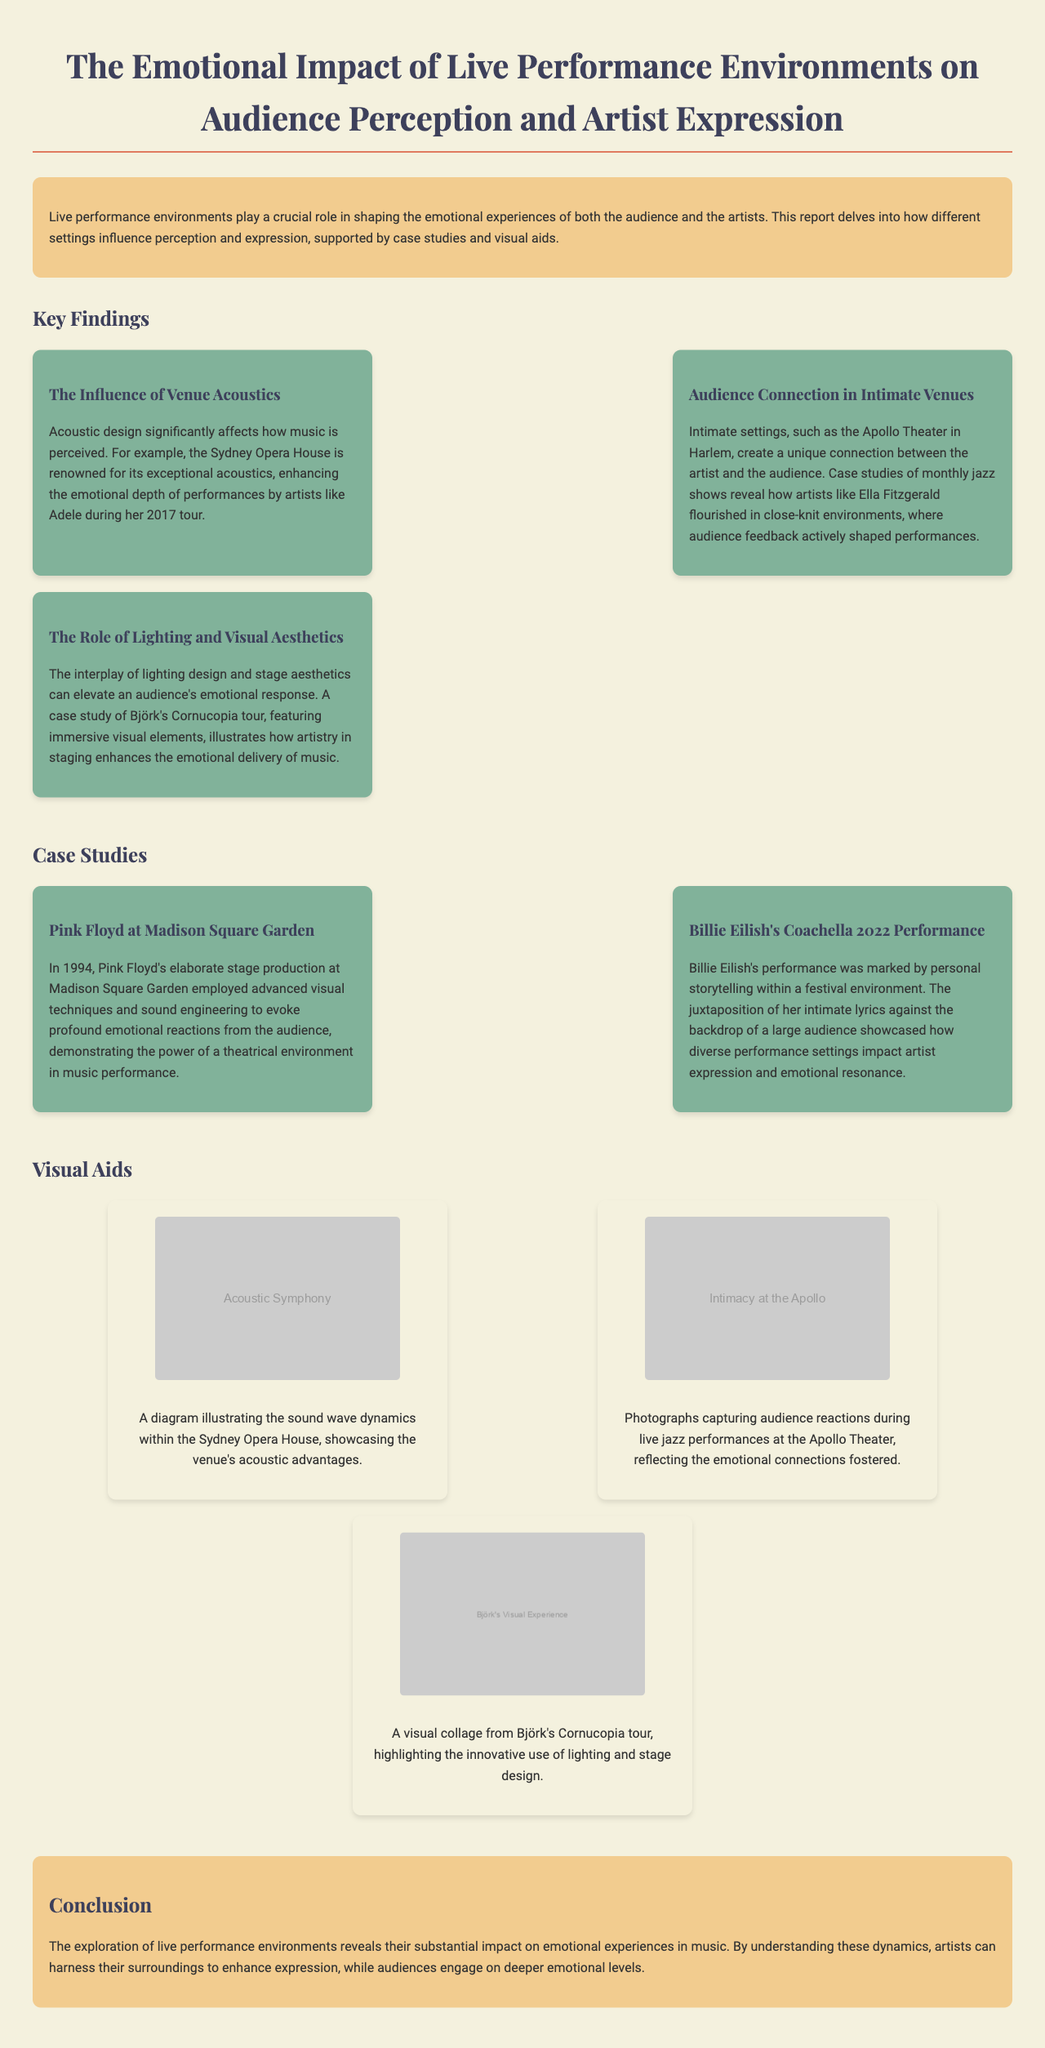what is the title of the report? The title is prominently displayed at the top of the document, indicating the subject matter of the report.
Answer: The Emotional Impact of Live Performance Environments on Audience Perception and Artist Expression who is highlighted for exceptional acoustics in the report? The report mentions the Sydney Opera House as a notable example of exceptional acoustics affecting music perception.
Answer: Sydney Opera House what year did Pink Floyd perform at Madison Square Garden? The performance date is provided within the context of the case study discussing Pink Floyd's elaborate production.
Answer: 1994 which artist's performance included personal storytelling at Coachella? The report specifically references Billie Eilish and discusses her performance context.
Answer: Billie Eilish what unique connection is mentioned in intimate venues? The report describes the connection created in intimate settings through audience feedback affecting performances.
Answer: Unique connection which element is crucial in enhancing emotional delivery according to the report? The report discusses the interplay of lighting design and stage aesthetics as elements enhancing emotional response.
Answer: Lighting and Visual Aesthetics what does the conclusion suggest artists can harness to enhance expression? The conclusion provides insights about the impact of performance environments on artists.
Answer: Surroundings how many visual aids are included in the report? The report contains a section with visual aids depicting different aspects of live performances.
Answer: Three 